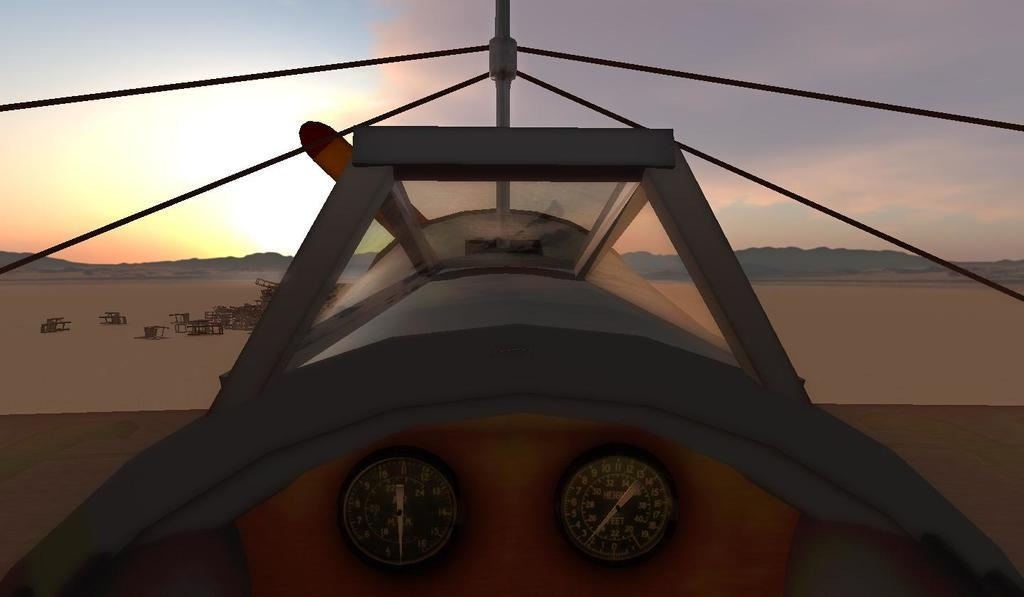<image>
Summarize the visual content of the image. A plane with two gauges, with the one on the right registering the altitude in feet. 